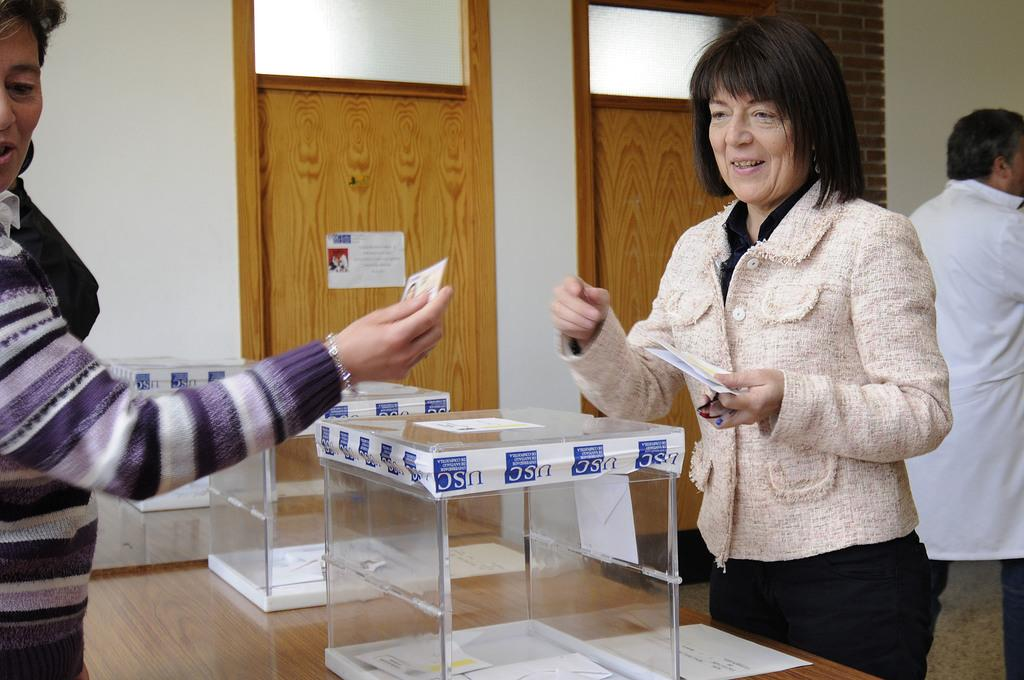How many people are in the image? There are persons standing in the image, but the exact number cannot be determined from the provided facts. What is on the table in the image? There is a glass box on a table in the image. What can be seen in the background of the image? There is a door and a wall visible in the background of the image. What type of gold nest can be seen in the image? There is no gold nest present in the image. How does the behavior of the persons in the image change throughout the day? The provided facts do not give any information about the behavior of the persons in the image or how it might change throughout the day. 